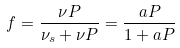<formula> <loc_0><loc_0><loc_500><loc_500>f = \frac { \nu P } { \nu _ { s } + \nu P } = \frac { a P } { 1 + a P }</formula> 